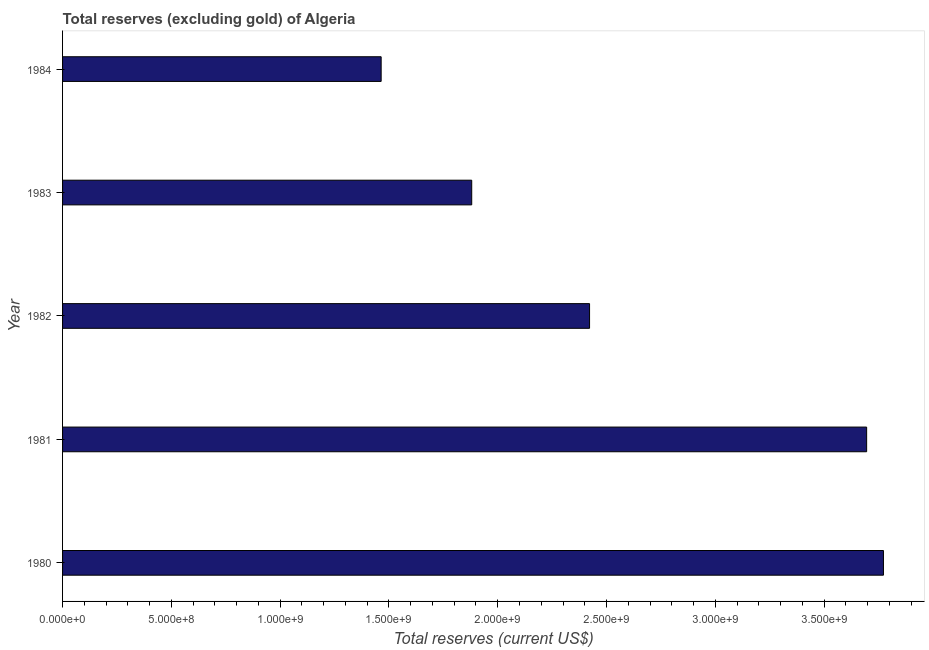Does the graph contain any zero values?
Your response must be concise. No. Does the graph contain grids?
Provide a succinct answer. No. What is the title of the graph?
Offer a terse response. Total reserves (excluding gold) of Algeria. What is the label or title of the X-axis?
Provide a short and direct response. Total reserves (current US$). What is the total reserves (excluding gold) in 1982?
Your answer should be compact. 2.42e+09. Across all years, what is the maximum total reserves (excluding gold)?
Your answer should be very brief. 3.77e+09. Across all years, what is the minimum total reserves (excluding gold)?
Provide a succinct answer. 1.46e+09. In which year was the total reserves (excluding gold) maximum?
Provide a succinct answer. 1980. What is the sum of the total reserves (excluding gold)?
Your answer should be compact. 1.32e+1. What is the difference between the total reserves (excluding gold) in 1980 and 1982?
Make the answer very short. 1.35e+09. What is the average total reserves (excluding gold) per year?
Your response must be concise. 2.65e+09. What is the median total reserves (excluding gold)?
Ensure brevity in your answer.  2.42e+09. What is the ratio of the total reserves (excluding gold) in 1980 to that in 1984?
Give a very brief answer. 2.58. Is the difference between the total reserves (excluding gold) in 1980 and 1984 greater than the difference between any two years?
Provide a short and direct response. Yes. What is the difference between the highest and the second highest total reserves (excluding gold)?
Ensure brevity in your answer.  7.73e+07. What is the difference between the highest and the lowest total reserves (excluding gold)?
Provide a short and direct response. 2.31e+09. How many bars are there?
Provide a short and direct response. 5. How many years are there in the graph?
Provide a short and direct response. 5. Are the values on the major ticks of X-axis written in scientific E-notation?
Give a very brief answer. Yes. What is the Total reserves (current US$) of 1980?
Ensure brevity in your answer.  3.77e+09. What is the Total reserves (current US$) of 1981?
Provide a short and direct response. 3.70e+09. What is the Total reserves (current US$) of 1982?
Provide a short and direct response. 2.42e+09. What is the Total reserves (current US$) in 1983?
Give a very brief answer. 1.88e+09. What is the Total reserves (current US$) of 1984?
Your answer should be very brief. 1.46e+09. What is the difference between the Total reserves (current US$) in 1980 and 1981?
Ensure brevity in your answer.  7.73e+07. What is the difference between the Total reserves (current US$) in 1980 and 1982?
Your answer should be very brief. 1.35e+09. What is the difference between the Total reserves (current US$) in 1980 and 1983?
Your answer should be very brief. 1.89e+09. What is the difference between the Total reserves (current US$) in 1980 and 1984?
Give a very brief answer. 2.31e+09. What is the difference between the Total reserves (current US$) in 1981 and 1982?
Your response must be concise. 1.27e+09. What is the difference between the Total reserves (current US$) in 1981 and 1983?
Your response must be concise. 1.81e+09. What is the difference between the Total reserves (current US$) in 1981 and 1984?
Your answer should be compact. 2.23e+09. What is the difference between the Total reserves (current US$) in 1982 and 1983?
Provide a short and direct response. 5.42e+08. What is the difference between the Total reserves (current US$) in 1982 and 1984?
Ensure brevity in your answer.  9.58e+08. What is the difference between the Total reserves (current US$) in 1983 and 1984?
Give a very brief answer. 4.16e+08. What is the ratio of the Total reserves (current US$) in 1980 to that in 1982?
Your response must be concise. 1.56. What is the ratio of the Total reserves (current US$) in 1980 to that in 1983?
Give a very brief answer. 2.01. What is the ratio of the Total reserves (current US$) in 1980 to that in 1984?
Offer a very short reply. 2.58. What is the ratio of the Total reserves (current US$) in 1981 to that in 1982?
Your answer should be very brief. 1.53. What is the ratio of the Total reserves (current US$) in 1981 to that in 1983?
Make the answer very short. 1.97. What is the ratio of the Total reserves (current US$) in 1981 to that in 1984?
Offer a terse response. 2.52. What is the ratio of the Total reserves (current US$) in 1982 to that in 1983?
Provide a short and direct response. 1.29. What is the ratio of the Total reserves (current US$) in 1982 to that in 1984?
Offer a terse response. 1.65. What is the ratio of the Total reserves (current US$) in 1983 to that in 1984?
Make the answer very short. 1.28. 